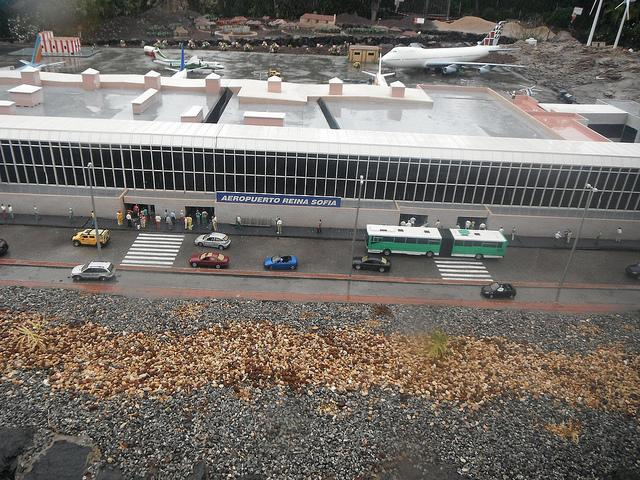What country is this location?

Choices:
A) canada
B) spain
C) mexico
D) france spain 